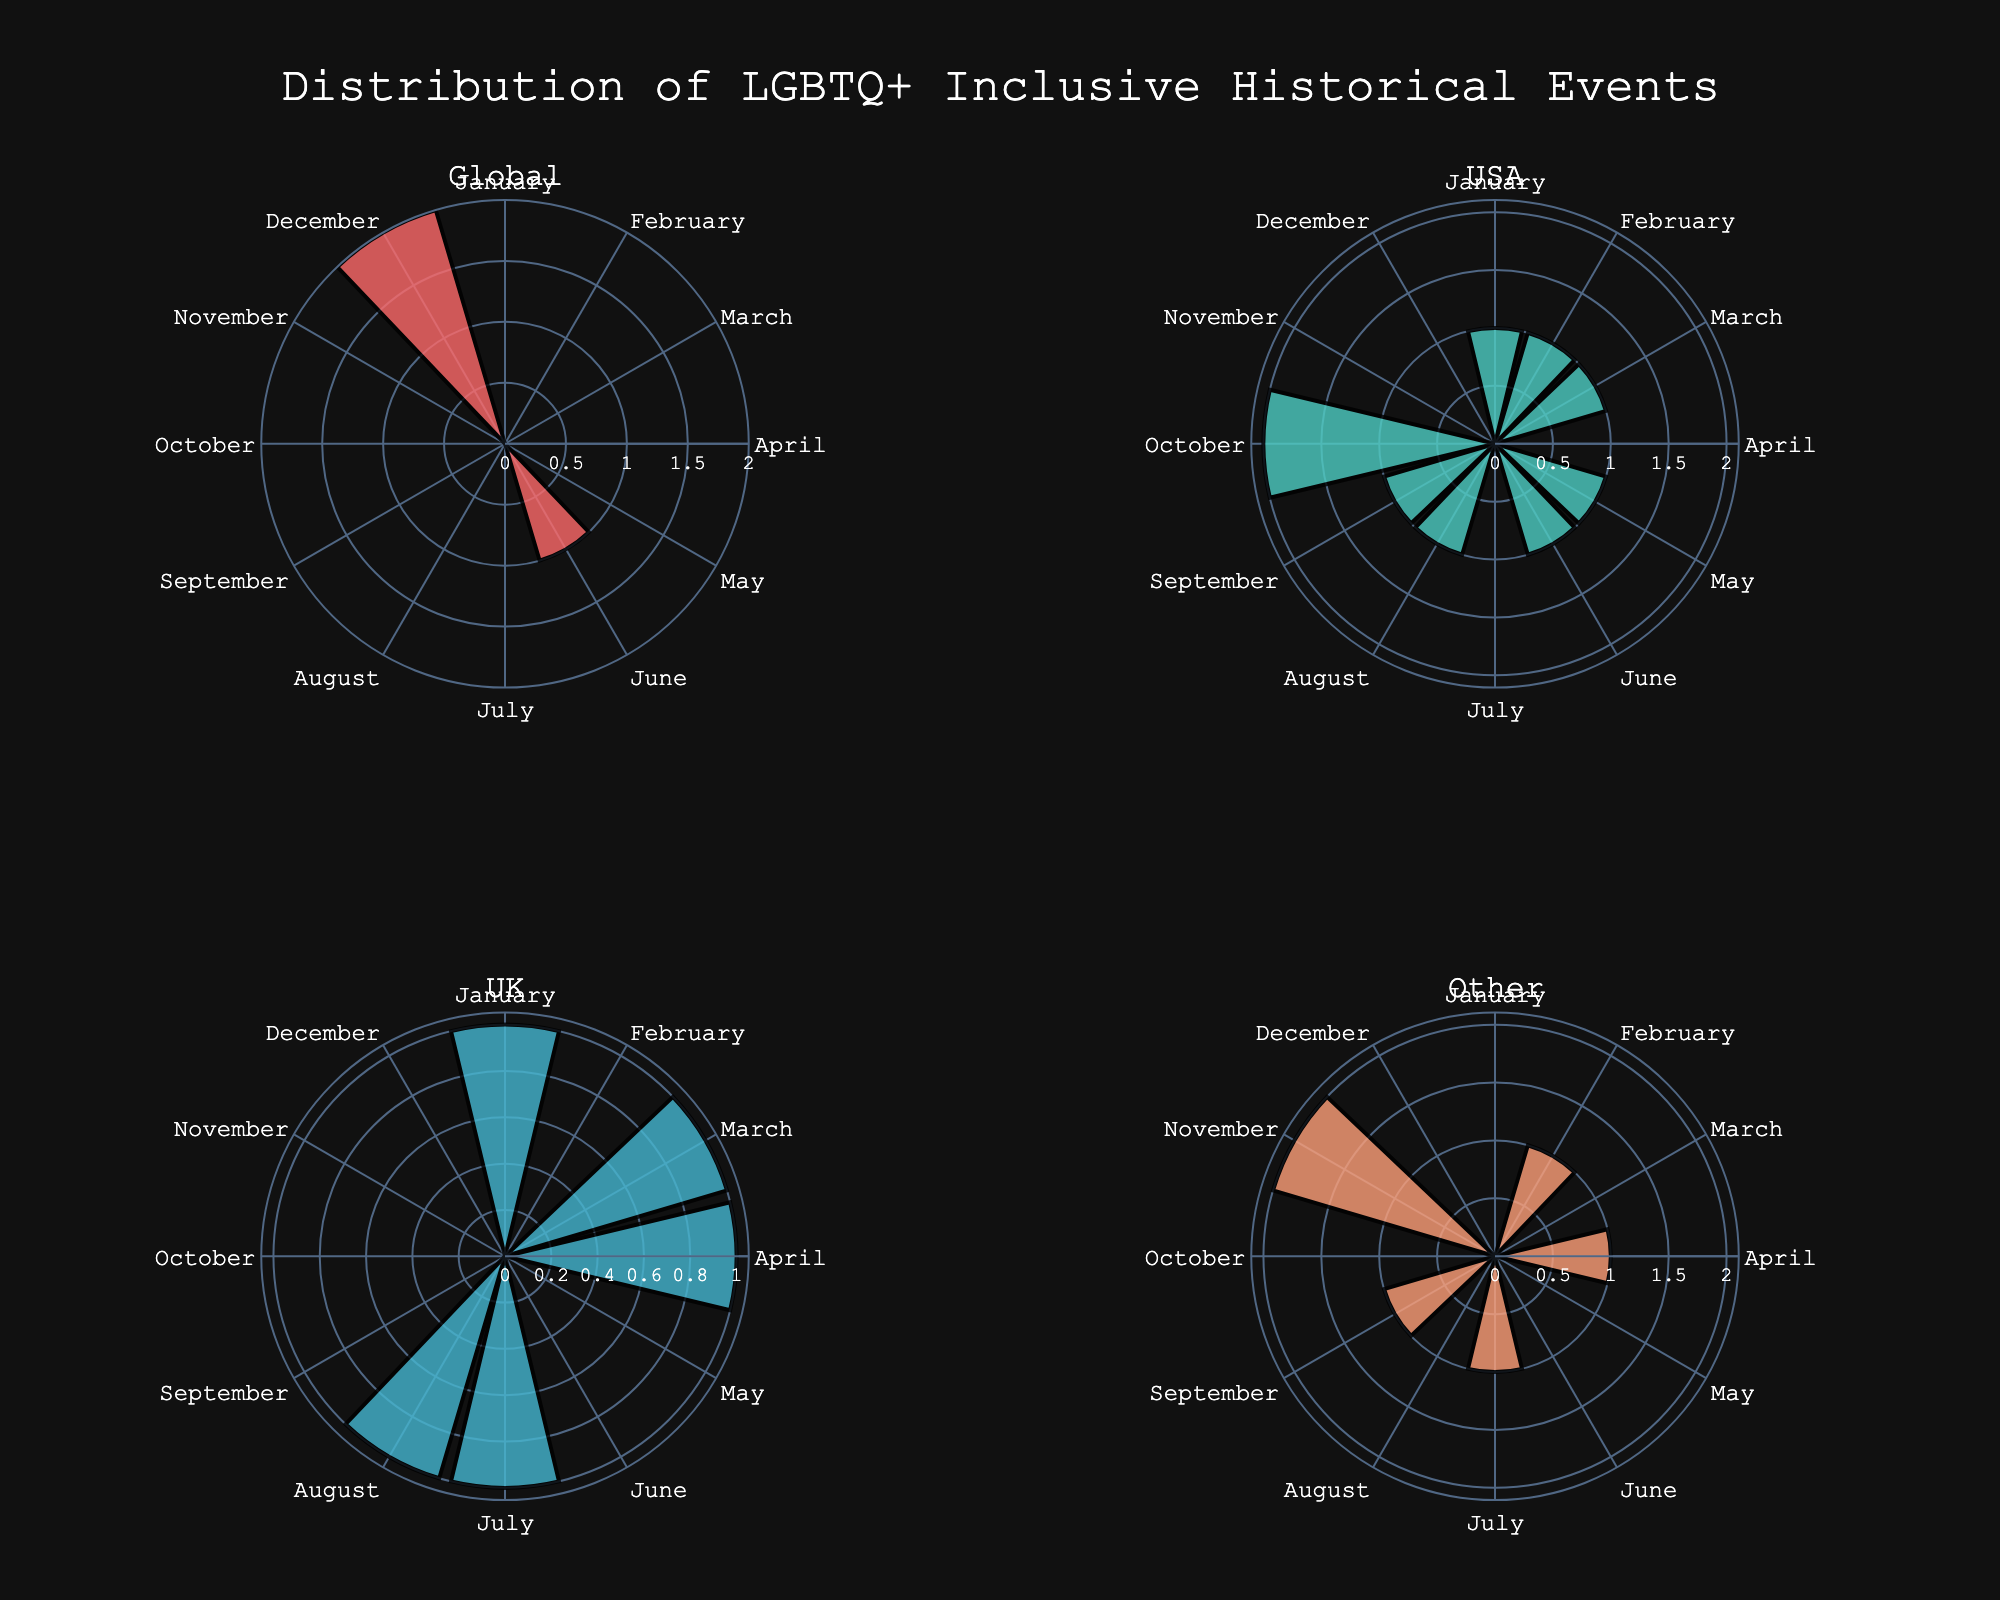what is the title of the figure? The title of the figure is positioned at the top and clearly displays the main topic. It reads "Distribution of LGBTQ+ Inclusive Historical Events".
Answer: Distribution of LGBTQ+ Inclusive Historical Events Which month has the highest number of events globally? By looking at the "Global" subplot in the figure, we can observe the radial length of each month representing the count of events. The month with the longest bar is June.
Answer: June How many LGBTQ+ inclusive historical events are celebrated in the USA in October? To determine this, we examine the USA subplot. October shows two radial bars, indicating the number of events in that month.
Answer: 2 Compare the number of events in January in the UK and Other countries. Which has more events? In the UK subplot, January has two radial bars while the Other subplot shows no events in January, indicating that the UK has more events in January.
Answer: UK In which month does the UK have the same number of events as Other countries? By comparing the radial lengths in both subplots, we find that in August, both have the same radial bar length indicating one event each.
Answer: August Which month has the second highest number of events in the UK? Observing the lengths of the radial bars in the UK subplot, June has the highest and July the second highest.
Answer: July How many months have no events in the "Other" subplot? By identifying the months with zero-length radial bars in the Other subplot, we count seven months with no events.
Answer: 7 Is there a month where all four subplots have events? If so, which month? Comparing the radial bars across all four subplots, June is the only month where all subplots have events.
Answer: June What is the total number of events in November across all subplots? Summing the radial bars for November in all subplots, we get one event in Other and one event in Global. Therefore, 1 (Other) + 1 (Global) = 2.
Answer: 2 What are the primary colors used in the different subplots? Observing the color of the radial bars, we see red for "Global", cyan for "USA", blue for "UK", and orange for "Other".
Answer: Red, cyan, blue, and orange 